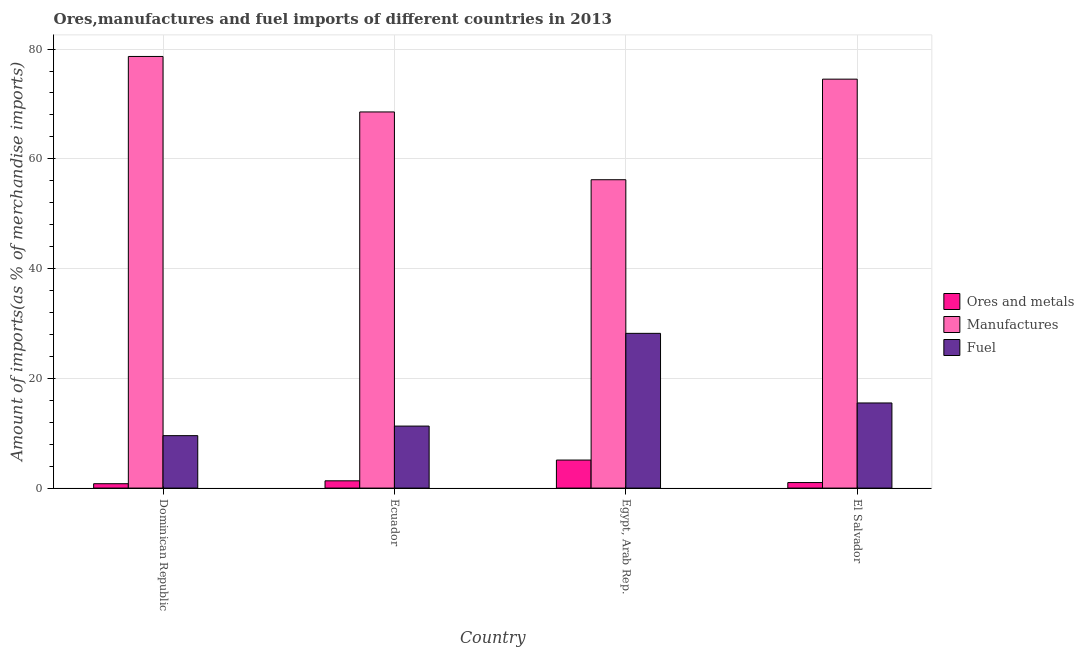Are the number of bars per tick equal to the number of legend labels?
Make the answer very short. Yes. Are the number of bars on each tick of the X-axis equal?
Your answer should be compact. Yes. How many bars are there on the 4th tick from the left?
Keep it short and to the point. 3. What is the label of the 3rd group of bars from the left?
Your answer should be very brief. Egypt, Arab Rep. What is the percentage of ores and metals imports in El Salvador?
Your answer should be very brief. 1.01. Across all countries, what is the maximum percentage of fuel imports?
Offer a very short reply. 28.2. Across all countries, what is the minimum percentage of ores and metals imports?
Make the answer very short. 0.8. In which country was the percentage of ores and metals imports maximum?
Your answer should be compact. Egypt, Arab Rep. In which country was the percentage of manufactures imports minimum?
Keep it short and to the point. Egypt, Arab Rep. What is the total percentage of ores and metals imports in the graph?
Provide a short and direct response. 8.24. What is the difference between the percentage of ores and metals imports in Ecuador and that in Egypt, Arab Rep.?
Your answer should be compact. -3.78. What is the difference between the percentage of fuel imports in Ecuador and the percentage of manufactures imports in El Salvador?
Your response must be concise. -63.22. What is the average percentage of manufactures imports per country?
Give a very brief answer. 69.48. What is the difference between the percentage of fuel imports and percentage of ores and metals imports in Egypt, Arab Rep.?
Your response must be concise. 23.09. What is the ratio of the percentage of fuel imports in Egypt, Arab Rep. to that in El Salvador?
Offer a very short reply. 1.82. Is the percentage of fuel imports in Dominican Republic less than that in Ecuador?
Your response must be concise. Yes. Is the difference between the percentage of fuel imports in Egypt, Arab Rep. and El Salvador greater than the difference between the percentage of ores and metals imports in Egypt, Arab Rep. and El Salvador?
Your answer should be compact. Yes. What is the difference between the highest and the second highest percentage of ores and metals imports?
Offer a terse response. 3.78. What is the difference between the highest and the lowest percentage of fuel imports?
Make the answer very short. 18.64. What does the 2nd bar from the left in Egypt, Arab Rep. represents?
Your answer should be very brief. Manufactures. What does the 2nd bar from the right in Dominican Republic represents?
Ensure brevity in your answer.  Manufactures. Is it the case that in every country, the sum of the percentage of ores and metals imports and percentage of manufactures imports is greater than the percentage of fuel imports?
Keep it short and to the point. Yes. Are all the bars in the graph horizontal?
Provide a succinct answer. No. Does the graph contain any zero values?
Your answer should be very brief. No. How many legend labels are there?
Keep it short and to the point. 3. How are the legend labels stacked?
Offer a terse response. Vertical. What is the title of the graph?
Your answer should be very brief. Ores,manufactures and fuel imports of different countries in 2013. Does "Methane" appear as one of the legend labels in the graph?
Give a very brief answer. No. What is the label or title of the Y-axis?
Keep it short and to the point. Amount of imports(as % of merchandise imports). What is the Amount of imports(as % of merchandise imports) in Ores and metals in Dominican Republic?
Offer a very short reply. 0.8. What is the Amount of imports(as % of merchandise imports) in Manufactures in Dominican Republic?
Your answer should be very brief. 78.65. What is the Amount of imports(as % of merchandise imports) in Fuel in Dominican Republic?
Give a very brief answer. 9.56. What is the Amount of imports(as % of merchandise imports) of Ores and metals in Ecuador?
Keep it short and to the point. 1.33. What is the Amount of imports(as % of merchandise imports) of Manufactures in Ecuador?
Your response must be concise. 68.54. What is the Amount of imports(as % of merchandise imports) of Fuel in Ecuador?
Give a very brief answer. 11.3. What is the Amount of imports(as % of merchandise imports) in Ores and metals in Egypt, Arab Rep.?
Your answer should be very brief. 5.11. What is the Amount of imports(as % of merchandise imports) in Manufactures in Egypt, Arab Rep.?
Offer a terse response. 56.19. What is the Amount of imports(as % of merchandise imports) of Fuel in Egypt, Arab Rep.?
Give a very brief answer. 28.2. What is the Amount of imports(as % of merchandise imports) of Ores and metals in El Salvador?
Give a very brief answer. 1.01. What is the Amount of imports(as % of merchandise imports) of Manufactures in El Salvador?
Your answer should be compact. 74.52. What is the Amount of imports(as % of merchandise imports) of Fuel in El Salvador?
Your response must be concise. 15.51. Across all countries, what is the maximum Amount of imports(as % of merchandise imports) in Ores and metals?
Provide a succinct answer. 5.11. Across all countries, what is the maximum Amount of imports(as % of merchandise imports) of Manufactures?
Keep it short and to the point. 78.65. Across all countries, what is the maximum Amount of imports(as % of merchandise imports) in Fuel?
Provide a short and direct response. 28.2. Across all countries, what is the minimum Amount of imports(as % of merchandise imports) of Ores and metals?
Provide a short and direct response. 0.8. Across all countries, what is the minimum Amount of imports(as % of merchandise imports) in Manufactures?
Your answer should be compact. 56.19. Across all countries, what is the minimum Amount of imports(as % of merchandise imports) of Fuel?
Provide a short and direct response. 9.56. What is the total Amount of imports(as % of merchandise imports) of Ores and metals in the graph?
Your response must be concise. 8.24. What is the total Amount of imports(as % of merchandise imports) in Manufactures in the graph?
Your answer should be very brief. 277.91. What is the total Amount of imports(as % of merchandise imports) in Fuel in the graph?
Your answer should be very brief. 64.57. What is the difference between the Amount of imports(as % of merchandise imports) of Ores and metals in Dominican Republic and that in Ecuador?
Keep it short and to the point. -0.53. What is the difference between the Amount of imports(as % of merchandise imports) of Manufactures in Dominican Republic and that in Ecuador?
Ensure brevity in your answer.  10.11. What is the difference between the Amount of imports(as % of merchandise imports) in Fuel in Dominican Republic and that in Ecuador?
Your answer should be very brief. -1.74. What is the difference between the Amount of imports(as % of merchandise imports) in Ores and metals in Dominican Republic and that in Egypt, Arab Rep.?
Ensure brevity in your answer.  -4.31. What is the difference between the Amount of imports(as % of merchandise imports) of Manufactures in Dominican Republic and that in Egypt, Arab Rep.?
Offer a very short reply. 22.46. What is the difference between the Amount of imports(as % of merchandise imports) of Fuel in Dominican Republic and that in Egypt, Arab Rep.?
Provide a short and direct response. -18.64. What is the difference between the Amount of imports(as % of merchandise imports) in Ores and metals in Dominican Republic and that in El Salvador?
Offer a terse response. -0.21. What is the difference between the Amount of imports(as % of merchandise imports) in Manufactures in Dominican Republic and that in El Salvador?
Ensure brevity in your answer.  4.13. What is the difference between the Amount of imports(as % of merchandise imports) in Fuel in Dominican Republic and that in El Salvador?
Keep it short and to the point. -5.95. What is the difference between the Amount of imports(as % of merchandise imports) of Ores and metals in Ecuador and that in Egypt, Arab Rep.?
Offer a terse response. -3.78. What is the difference between the Amount of imports(as % of merchandise imports) in Manufactures in Ecuador and that in Egypt, Arab Rep.?
Keep it short and to the point. 12.35. What is the difference between the Amount of imports(as % of merchandise imports) in Fuel in Ecuador and that in Egypt, Arab Rep.?
Ensure brevity in your answer.  -16.9. What is the difference between the Amount of imports(as % of merchandise imports) in Ores and metals in Ecuador and that in El Salvador?
Make the answer very short. 0.32. What is the difference between the Amount of imports(as % of merchandise imports) in Manufactures in Ecuador and that in El Salvador?
Offer a terse response. -5.98. What is the difference between the Amount of imports(as % of merchandise imports) in Fuel in Ecuador and that in El Salvador?
Offer a terse response. -4.21. What is the difference between the Amount of imports(as % of merchandise imports) of Ores and metals in Egypt, Arab Rep. and that in El Salvador?
Keep it short and to the point. 4.1. What is the difference between the Amount of imports(as % of merchandise imports) of Manufactures in Egypt, Arab Rep. and that in El Salvador?
Your answer should be very brief. -18.33. What is the difference between the Amount of imports(as % of merchandise imports) of Fuel in Egypt, Arab Rep. and that in El Salvador?
Provide a short and direct response. 12.69. What is the difference between the Amount of imports(as % of merchandise imports) of Ores and metals in Dominican Republic and the Amount of imports(as % of merchandise imports) of Manufactures in Ecuador?
Offer a terse response. -67.74. What is the difference between the Amount of imports(as % of merchandise imports) in Ores and metals in Dominican Republic and the Amount of imports(as % of merchandise imports) in Fuel in Ecuador?
Offer a terse response. -10.5. What is the difference between the Amount of imports(as % of merchandise imports) in Manufactures in Dominican Republic and the Amount of imports(as % of merchandise imports) in Fuel in Ecuador?
Offer a very short reply. 67.35. What is the difference between the Amount of imports(as % of merchandise imports) in Ores and metals in Dominican Republic and the Amount of imports(as % of merchandise imports) in Manufactures in Egypt, Arab Rep.?
Make the answer very short. -55.39. What is the difference between the Amount of imports(as % of merchandise imports) in Ores and metals in Dominican Republic and the Amount of imports(as % of merchandise imports) in Fuel in Egypt, Arab Rep.?
Make the answer very short. -27.4. What is the difference between the Amount of imports(as % of merchandise imports) in Manufactures in Dominican Republic and the Amount of imports(as % of merchandise imports) in Fuel in Egypt, Arab Rep.?
Offer a very short reply. 50.46. What is the difference between the Amount of imports(as % of merchandise imports) of Ores and metals in Dominican Republic and the Amount of imports(as % of merchandise imports) of Manufactures in El Salvador?
Offer a terse response. -73.72. What is the difference between the Amount of imports(as % of merchandise imports) of Ores and metals in Dominican Republic and the Amount of imports(as % of merchandise imports) of Fuel in El Salvador?
Your answer should be compact. -14.71. What is the difference between the Amount of imports(as % of merchandise imports) in Manufactures in Dominican Republic and the Amount of imports(as % of merchandise imports) in Fuel in El Salvador?
Keep it short and to the point. 63.14. What is the difference between the Amount of imports(as % of merchandise imports) of Ores and metals in Ecuador and the Amount of imports(as % of merchandise imports) of Manufactures in Egypt, Arab Rep.?
Give a very brief answer. -54.87. What is the difference between the Amount of imports(as % of merchandise imports) in Ores and metals in Ecuador and the Amount of imports(as % of merchandise imports) in Fuel in Egypt, Arab Rep.?
Offer a terse response. -26.87. What is the difference between the Amount of imports(as % of merchandise imports) in Manufactures in Ecuador and the Amount of imports(as % of merchandise imports) in Fuel in Egypt, Arab Rep.?
Your answer should be very brief. 40.34. What is the difference between the Amount of imports(as % of merchandise imports) of Ores and metals in Ecuador and the Amount of imports(as % of merchandise imports) of Manufactures in El Salvador?
Make the answer very short. -73.19. What is the difference between the Amount of imports(as % of merchandise imports) of Ores and metals in Ecuador and the Amount of imports(as % of merchandise imports) of Fuel in El Salvador?
Offer a terse response. -14.19. What is the difference between the Amount of imports(as % of merchandise imports) of Manufactures in Ecuador and the Amount of imports(as % of merchandise imports) of Fuel in El Salvador?
Offer a terse response. 53.03. What is the difference between the Amount of imports(as % of merchandise imports) in Ores and metals in Egypt, Arab Rep. and the Amount of imports(as % of merchandise imports) in Manufactures in El Salvador?
Provide a succinct answer. -69.41. What is the difference between the Amount of imports(as % of merchandise imports) of Ores and metals in Egypt, Arab Rep. and the Amount of imports(as % of merchandise imports) of Fuel in El Salvador?
Your response must be concise. -10.4. What is the difference between the Amount of imports(as % of merchandise imports) in Manufactures in Egypt, Arab Rep. and the Amount of imports(as % of merchandise imports) in Fuel in El Salvador?
Your answer should be compact. 40.68. What is the average Amount of imports(as % of merchandise imports) of Ores and metals per country?
Your answer should be very brief. 2.06. What is the average Amount of imports(as % of merchandise imports) of Manufactures per country?
Your response must be concise. 69.48. What is the average Amount of imports(as % of merchandise imports) of Fuel per country?
Provide a succinct answer. 16.14. What is the difference between the Amount of imports(as % of merchandise imports) in Ores and metals and Amount of imports(as % of merchandise imports) in Manufactures in Dominican Republic?
Offer a very short reply. -77.86. What is the difference between the Amount of imports(as % of merchandise imports) of Ores and metals and Amount of imports(as % of merchandise imports) of Fuel in Dominican Republic?
Make the answer very short. -8.76. What is the difference between the Amount of imports(as % of merchandise imports) in Manufactures and Amount of imports(as % of merchandise imports) in Fuel in Dominican Republic?
Provide a succinct answer. 69.1. What is the difference between the Amount of imports(as % of merchandise imports) in Ores and metals and Amount of imports(as % of merchandise imports) in Manufactures in Ecuador?
Your answer should be compact. -67.22. What is the difference between the Amount of imports(as % of merchandise imports) in Ores and metals and Amount of imports(as % of merchandise imports) in Fuel in Ecuador?
Your answer should be very brief. -9.97. What is the difference between the Amount of imports(as % of merchandise imports) in Manufactures and Amount of imports(as % of merchandise imports) in Fuel in Ecuador?
Your answer should be very brief. 57.24. What is the difference between the Amount of imports(as % of merchandise imports) in Ores and metals and Amount of imports(as % of merchandise imports) in Manufactures in Egypt, Arab Rep.?
Keep it short and to the point. -51.08. What is the difference between the Amount of imports(as % of merchandise imports) of Ores and metals and Amount of imports(as % of merchandise imports) of Fuel in Egypt, Arab Rep.?
Ensure brevity in your answer.  -23.09. What is the difference between the Amount of imports(as % of merchandise imports) of Manufactures and Amount of imports(as % of merchandise imports) of Fuel in Egypt, Arab Rep.?
Your response must be concise. 27.99. What is the difference between the Amount of imports(as % of merchandise imports) in Ores and metals and Amount of imports(as % of merchandise imports) in Manufactures in El Salvador?
Keep it short and to the point. -73.51. What is the difference between the Amount of imports(as % of merchandise imports) of Ores and metals and Amount of imports(as % of merchandise imports) of Fuel in El Salvador?
Offer a terse response. -14.5. What is the difference between the Amount of imports(as % of merchandise imports) in Manufactures and Amount of imports(as % of merchandise imports) in Fuel in El Salvador?
Your response must be concise. 59.01. What is the ratio of the Amount of imports(as % of merchandise imports) of Ores and metals in Dominican Republic to that in Ecuador?
Provide a succinct answer. 0.6. What is the ratio of the Amount of imports(as % of merchandise imports) in Manufactures in Dominican Republic to that in Ecuador?
Keep it short and to the point. 1.15. What is the ratio of the Amount of imports(as % of merchandise imports) of Fuel in Dominican Republic to that in Ecuador?
Your answer should be compact. 0.85. What is the ratio of the Amount of imports(as % of merchandise imports) in Ores and metals in Dominican Republic to that in Egypt, Arab Rep.?
Your response must be concise. 0.16. What is the ratio of the Amount of imports(as % of merchandise imports) of Manufactures in Dominican Republic to that in Egypt, Arab Rep.?
Offer a very short reply. 1.4. What is the ratio of the Amount of imports(as % of merchandise imports) in Fuel in Dominican Republic to that in Egypt, Arab Rep.?
Your response must be concise. 0.34. What is the ratio of the Amount of imports(as % of merchandise imports) of Ores and metals in Dominican Republic to that in El Salvador?
Make the answer very short. 0.79. What is the ratio of the Amount of imports(as % of merchandise imports) of Manufactures in Dominican Republic to that in El Salvador?
Ensure brevity in your answer.  1.06. What is the ratio of the Amount of imports(as % of merchandise imports) in Fuel in Dominican Republic to that in El Salvador?
Your response must be concise. 0.62. What is the ratio of the Amount of imports(as % of merchandise imports) in Ores and metals in Ecuador to that in Egypt, Arab Rep.?
Make the answer very short. 0.26. What is the ratio of the Amount of imports(as % of merchandise imports) in Manufactures in Ecuador to that in Egypt, Arab Rep.?
Give a very brief answer. 1.22. What is the ratio of the Amount of imports(as % of merchandise imports) in Fuel in Ecuador to that in Egypt, Arab Rep.?
Make the answer very short. 0.4. What is the ratio of the Amount of imports(as % of merchandise imports) of Ores and metals in Ecuador to that in El Salvador?
Provide a succinct answer. 1.31. What is the ratio of the Amount of imports(as % of merchandise imports) of Manufactures in Ecuador to that in El Salvador?
Keep it short and to the point. 0.92. What is the ratio of the Amount of imports(as % of merchandise imports) of Fuel in Ecuador to that in El Salvador?
Your answer should be very brief. 0.73. What is the ratio of the Amount of imports(as % of merchandise imports) of Ores and metals in Egypt, Arab Rep. to that in El Salvador?
Your answer should be very brief. 5.06. What is the ratio of the Amount of imports(as % of merchandise imports) in Manufactures in Egypt, Arab Rep. to that in El Salvador?
Give a very brief answer. 0.75. What is the ratio of the Amount of imports(as % of merchandise imports) in Fuel in Egypt, Arab Rep. to that in El Salvador?
Provide a short and direct response. 1.82. What is the difference between the highest and the second highest Amount of imports(as % of merchandise imports) of Ores and metals?
Offer a terse response. 3.78. What is the difference between the highest and the second highest Amount of imports(as % of merchandise imports) in Manufactures?
Offer a terse response. 4.13. What is the difference between the highest and the second highest Amount of imports(as % of merchandise imports) of Fuel?
Your answer should be compact. 12.69. What is the difference between the highest and the lowest Amount of imports(as % of merchandise imports) in Ores and metals?
Offer a very short reply. 4.31. What is the difference between the highest and the lowest Amount of imports(as % of merchandise imports) of Manufactures?
Keep it short and to the point. 22.46. What is the difference between the highest and the lowest Amount of imports(as % of merchandise imports) in Fuel?
Your answer should be compact. 18.64. 